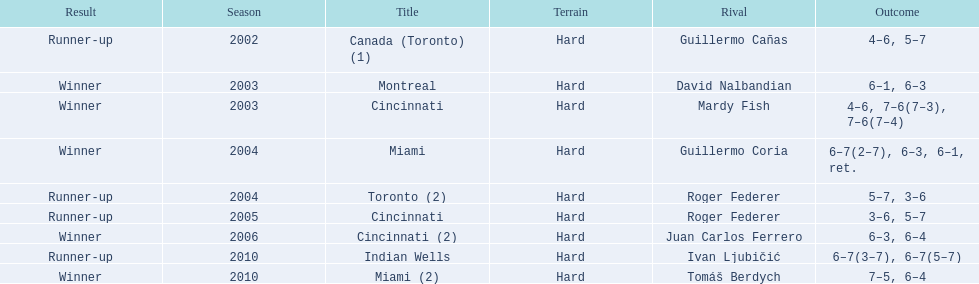Was roddick a runner-up or winner more? Winner. 